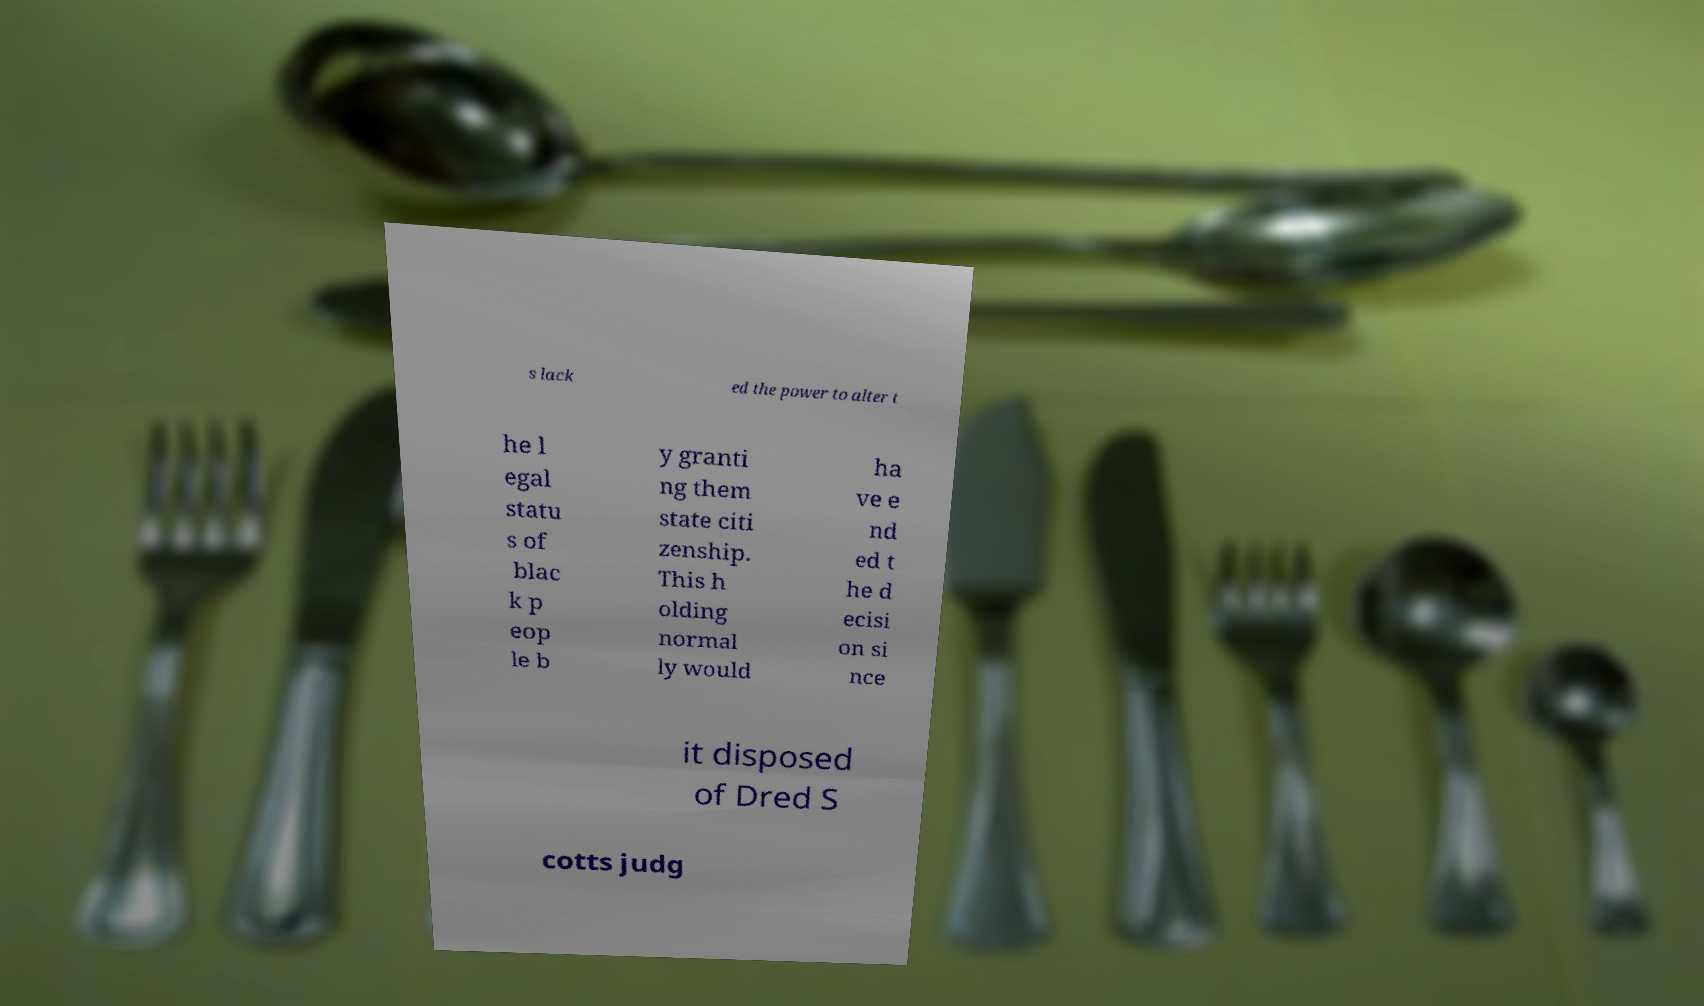There's text embedded in this image that I need extracted. Can you transcribe it verbatim? s lack ed the power to alter t he l egal statu s of blac k p eop le b y granti ng them state citi zenship. This h olding normal ly would ha ve e nd ed t he d ecisi on si nce it disposed of Dred S cotts judg 